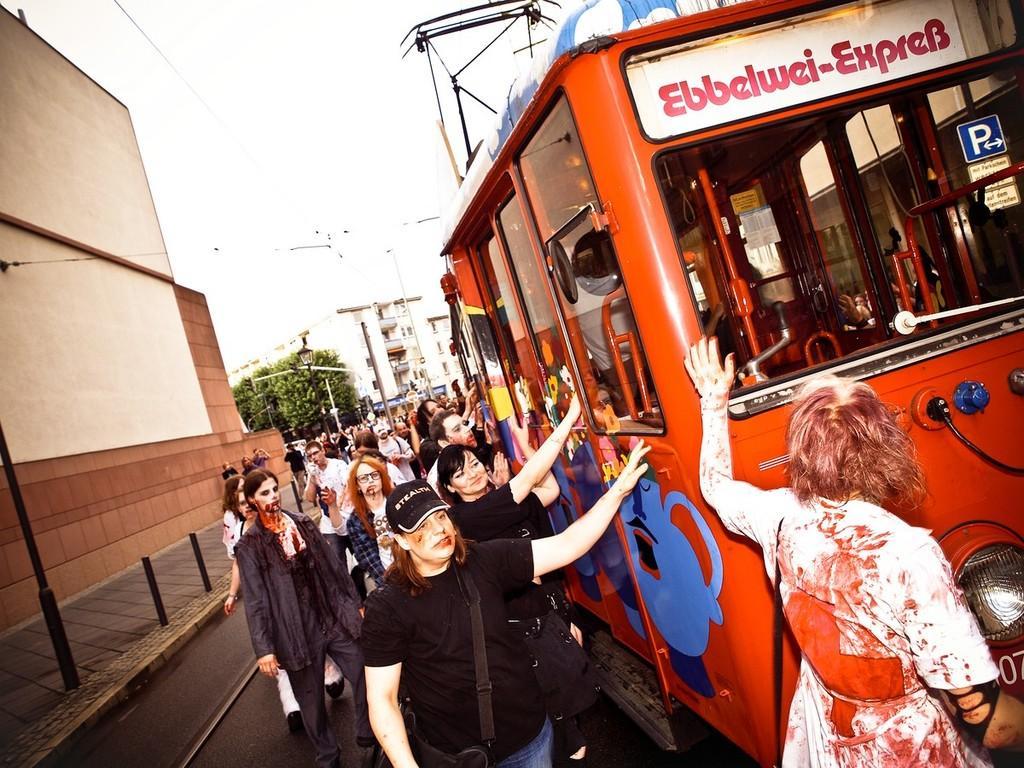How would you summarize this image in a sentence or two? In this image, we can see a group of people. On the right side, we can see a vehicle. At the bottom, there is a road. Left side of the image, we can see walkway, rods and wall. Background we can see trees, buildings, poles and street light. 